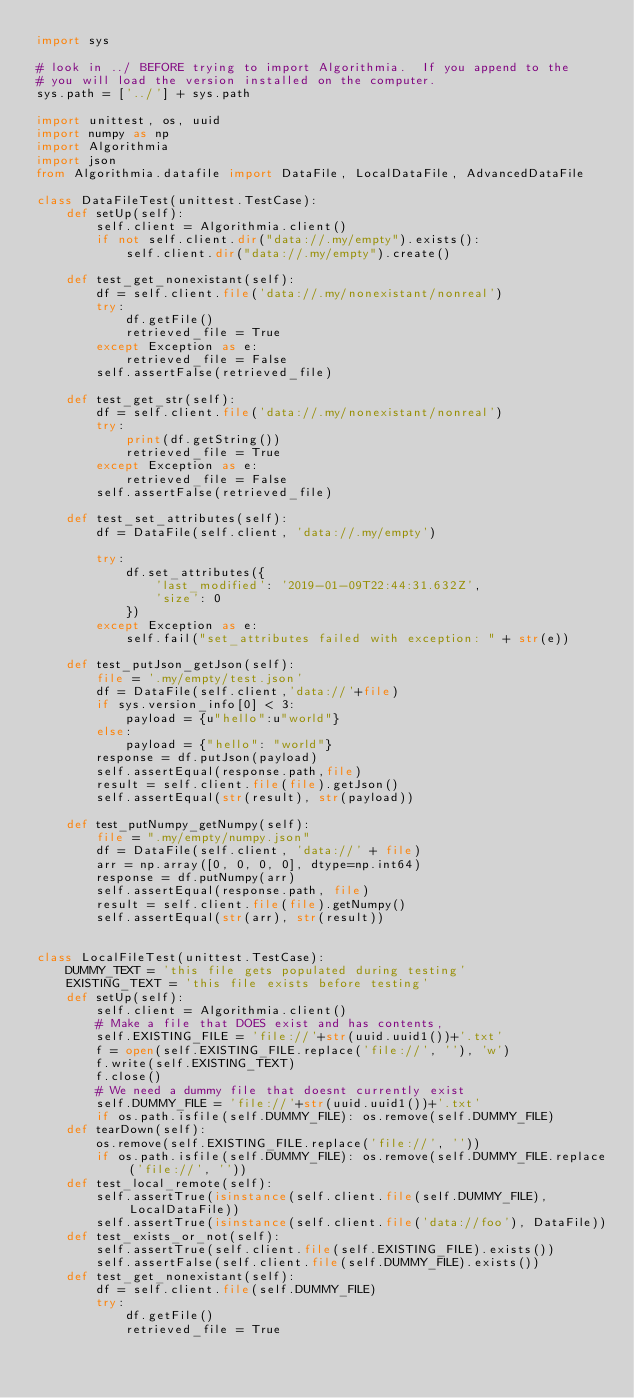<code> <loc_0><loc_0><loc_500><loc_500><_Python_>import sys

# look in ../ BEFORE trying to import Algorithmia.  If you append to the
# you will load the version installed on the computer.
sys.path = ['../'] + sys.path

import unittest, os, uuid
import numpy as np
import Algorithmia
import json
from Algorithmia.datafile import DataFile, LocalDataFile, AdvancedDataFile

class DataFileTest(unittest.TestCase):
    def setUp(self):
        self.client = Algorithmia.client()
        if not self.client.dir("data://.my/empty").exists():
            self.client.dir("data://.my/empty").create()

    def test_get_nonexistant(self):
        df = self.client.file('data://.my/nonexistant/nonreal')
        try:
            df.getFile()
            retrieved_file = True
        except Exception as e:
            retrieved_file = False
        self.assertFalse(retrieved_file)

    def test_get_str(self):
        df = self.client.file('data://.my/nonexistant/nonreal')
        try:
            print(df.getString())
            retrieved_file = True
        except Exception as e:
            retrieved_file = False
        self.assertFalse(retrieved_file)

    def test_set_attributes(self):
        df = DataFile(self.client, 'data://.my/empty')

        try:
            df.set_attributes({
                'last_modified': '2019-01-09T22:44:31.632Z',
                'size': 0
            })
        except Exception as e:
            self.fail("set_attributes failed with exception: " + str(e))

    def test_putJson_getJson(self):
        file = '.my/empty/test.json'
        df = DataFile(self.client,'data://'+file)
        if sys.version_info[0] < 3:
            payload = {u"hello":u"world"}
        else:
            payload = {"hello": "world"}
        response = df.putJson(payload)
        self.assertEqual(response.path,file)
        result = self.client.file(file).getJson()
        self.assertEqual(str(result), str(payload))

    def test_putNumpy_getNumpy(self):
        file = ".my/empty/numpy.json"
        df = DataFile(self.client, 'data://' + file)
        arr = np.array([0, 0, 0, 0], dtype=np.int64)
        response = df.putNumpy(arr)
        self.assertEqual(response.path, file)
        result = self.client.file(file).getNumpy()
        self.assertEqual(str(arr), str(result))

        
class LocalFileTest(unittest.TestCase):
    DUMMY_TEXT = 'this file gets populated during testing'
    EXISTING_TEXT = 'this file exists before testing'
    def setUp(self):
        self.client = Algorithmia.client()
        # Make a file that DOES exist and has contents,
        self.EXISTING_FILE = 'file://'+str(uuid.uuid1())+'.txt'
        f = open(self.EXISTING_FILE.replace('file://', ''), 'w')
        f.write(self.EXISTING_TEXT)
        f.close()
        # We need a dummy file that doesnt currently exist
        self.DUMMY_FILE = 'file://'+str(uuid.uuid1())+'.txt'
        if os.path.isfile(self.DUMMY_FILE): os.remove(self.DUMMY_FILE)
    def tearDown(self):
        os.remove(self.EXISTING_FILE.replace('file://', ''))
        if os.path.isfile(self.DUMMY_FILE): os.remove(self.DUMMY_FILE.replace('file://', ''))
    def test_local_remote(self):
        self.assertTrue(isinstance(self.client.file(self.DUMMY_FILE), LocalDataFile))
        self.assertTrue(isinstance(self.client.file('data://foo'), DataFile))
    def test_exists_or_not(self):
        self.assertTrue(self.client.file(self.EXISTING_FILE).exists())
        self.assertFalse(self.client.file(self.DUMMY_FILE).exists())
    def test_get_nonexistant(self):
        df = self.client.file(self.DUMMY_FILE)
        try:
            df.getFile()
            retrieved_file = True</code> 